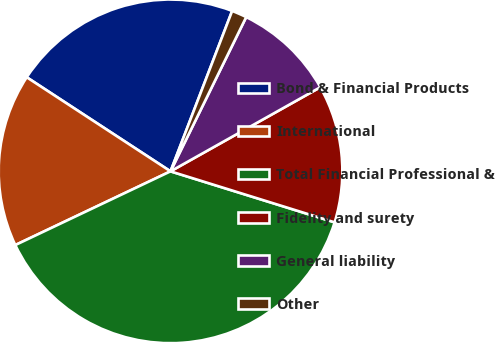Convert chart. <chart><loc_0><loc_0><loc_500><loc_500><pie_chart><fcel>Bond & Financial Products<fcel>International<fcel>Total Financial Professional &<fcel>Fidelity and surety<fcel>General liability<fcel>Other<nl><fcel>21.62%<fcel>16.28%<fcel>38.15%<fcel>12.94%<fcel>9.6%<fcel>1.42%<nl></chart> 